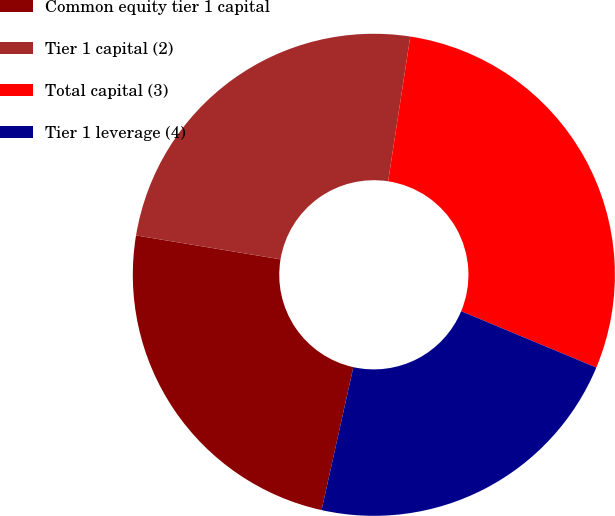Convert chart to OTSL. <chart><loc_0><loc_0><loc_500><loc_500><pie_chart><fcel>Common equity tier 1 capital<fcel>Tier 1 capital (2)<fcel>Total capital (3)<fcel>Tier 1 leverage (4)<nl><fcel>24.13%<fcel>24.8%<fcel>28.87%<fcel>22.19%<nl></chart> 